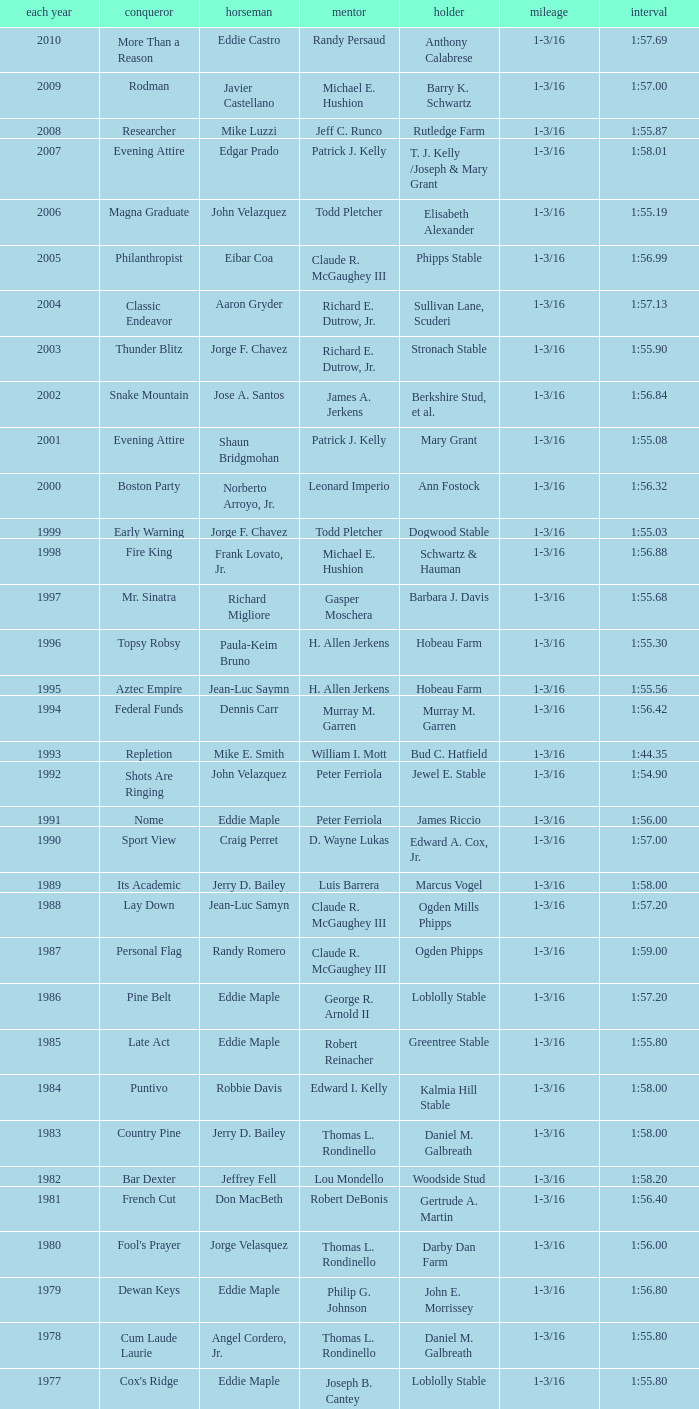When the winner was No Race in a year after 1909, what was the distance? 1 mile, 1 mile, 1 mile. 